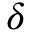Convert formula to latex. <formula><loc_0><loc_0><loc_500><loc_500>\delta</formula> 